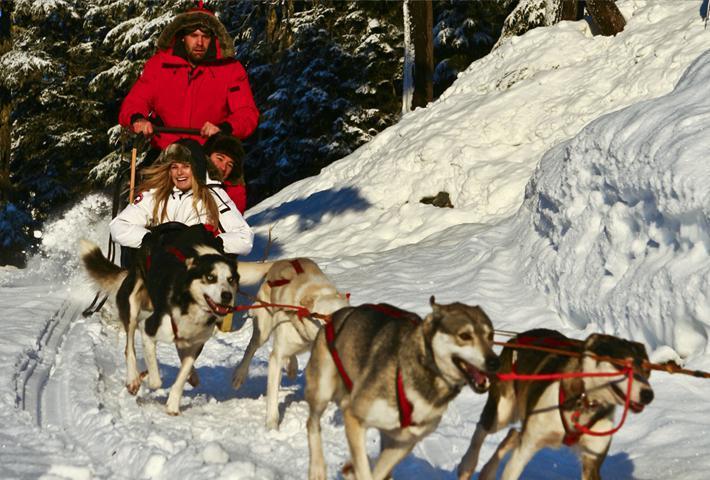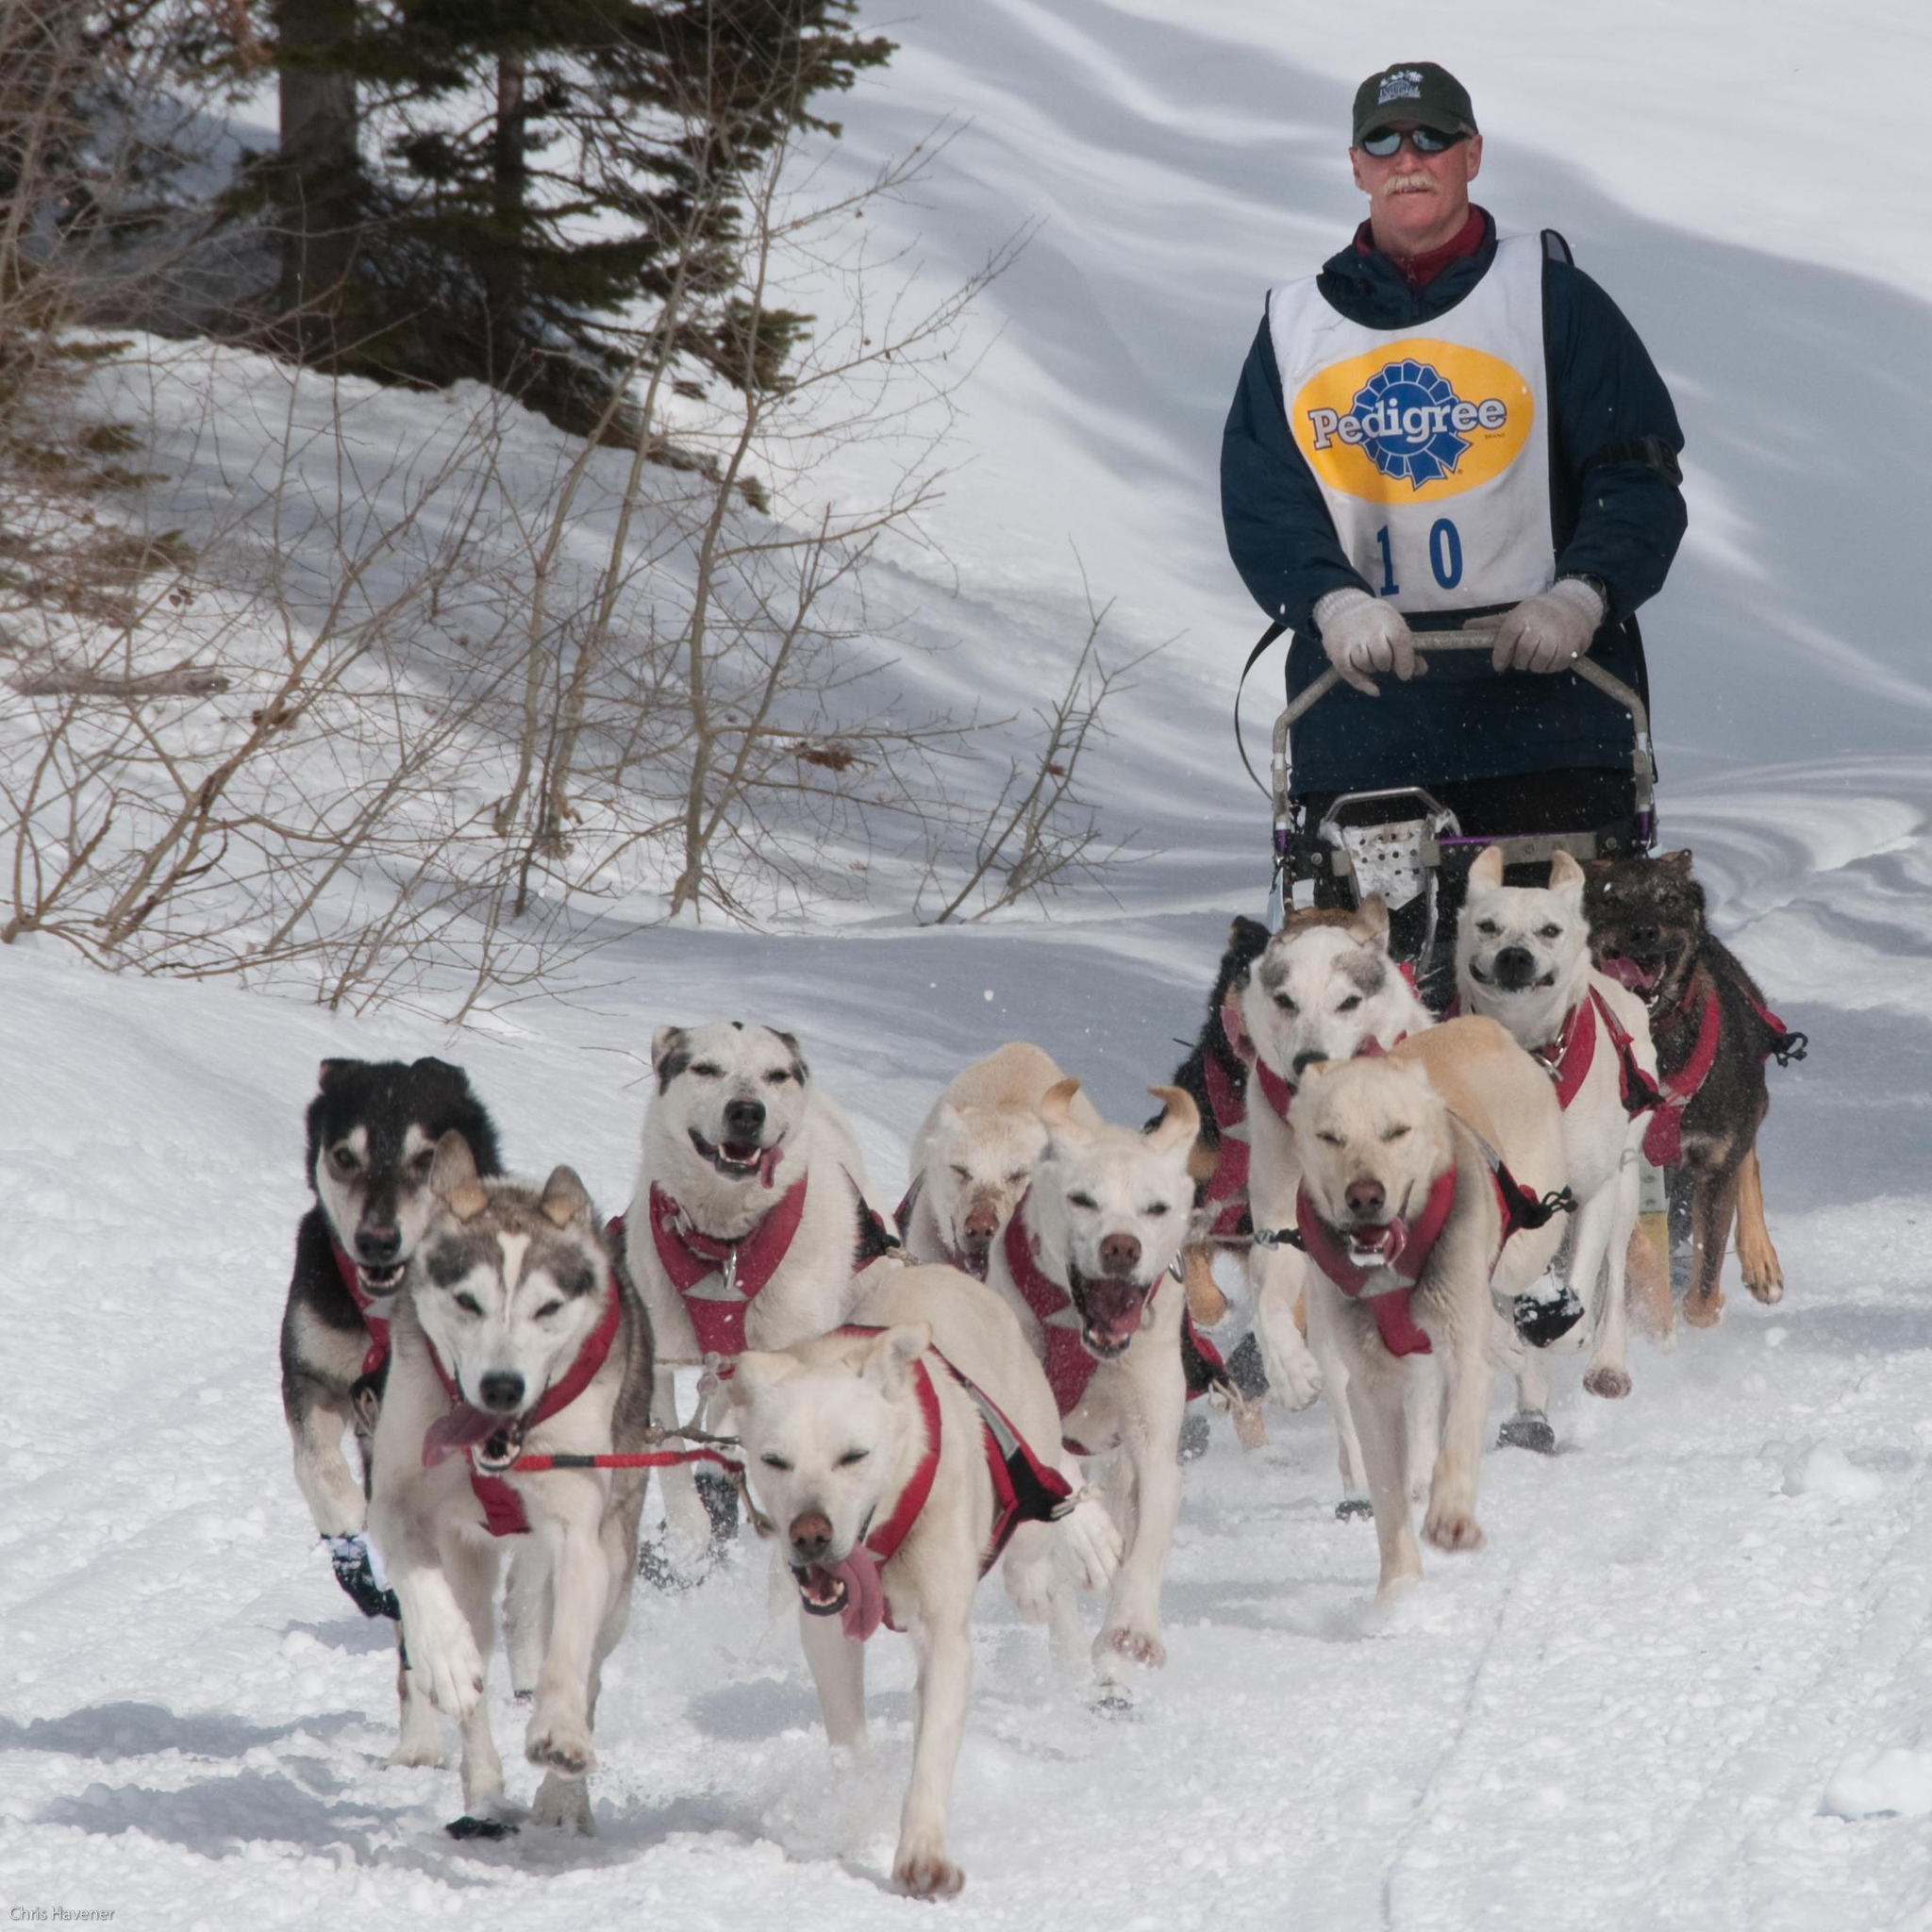The first image is the image on the left, the second image is the image on the right. Examine the images to the left and right. Is the description "there is a dog sled team pulling a sled with one person standing and 3 people inside the sled" accurate? Answer yes or no. No. The first image is the image on the left, the second image is the image on the right. For the images displayed, is the sentence "The man standing behind the sled in the image on the left is wearing a red jacket." factually correct? Answer yes or no. Yes. 